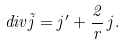Convert formula to latex. <formula><loc_0><loc_0><loc_500><loc_500>d i v \vec { j } = j ^ { \prime } + \frac { 2 } { r } \, j .</formula> 